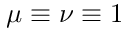Convert formula to latex. <formula><loc_0><loc_0><loc_500><loc_500>\mu \equiv \nu \equiv 1</formula> 